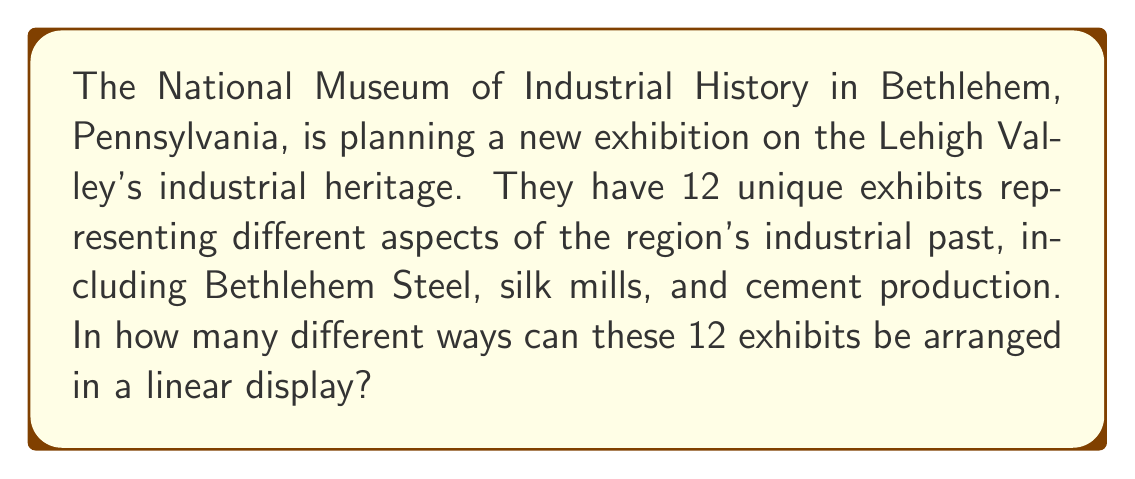Could you help me with this problem? Let's approach this step-by-step:

1) This problem is a straightforward application of permutations. We need to arrange 12 distinct objects in a line.

2) In permutation problems, when we have n distinct objects and we want to arrange all of them, the number of ways to do this is given by n!

3) In this case, n = 12 (the number of exhibits)

4) Therefore, the number of ways to arrange the exhibits is:

   $$12! = 12 \times 11 \times 10 \times 9 \times 8 \times 7 \times 6 \times 5 \times 4 \times 3 \times 2 \times 1$$

5) Let's calculate this:
   
   $$12! = 479,001,600$$

Thus, there are 479,001,600 different ways to arrange the 12 exhibits in the National Museum of Industrial History.
Answer: $479,001,600$ 